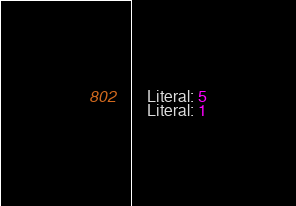Convert code to text. <code><loc_0><loc_0><loc_500><loc_500><_C_>    Literal: 5
    Literal: 1</code> 